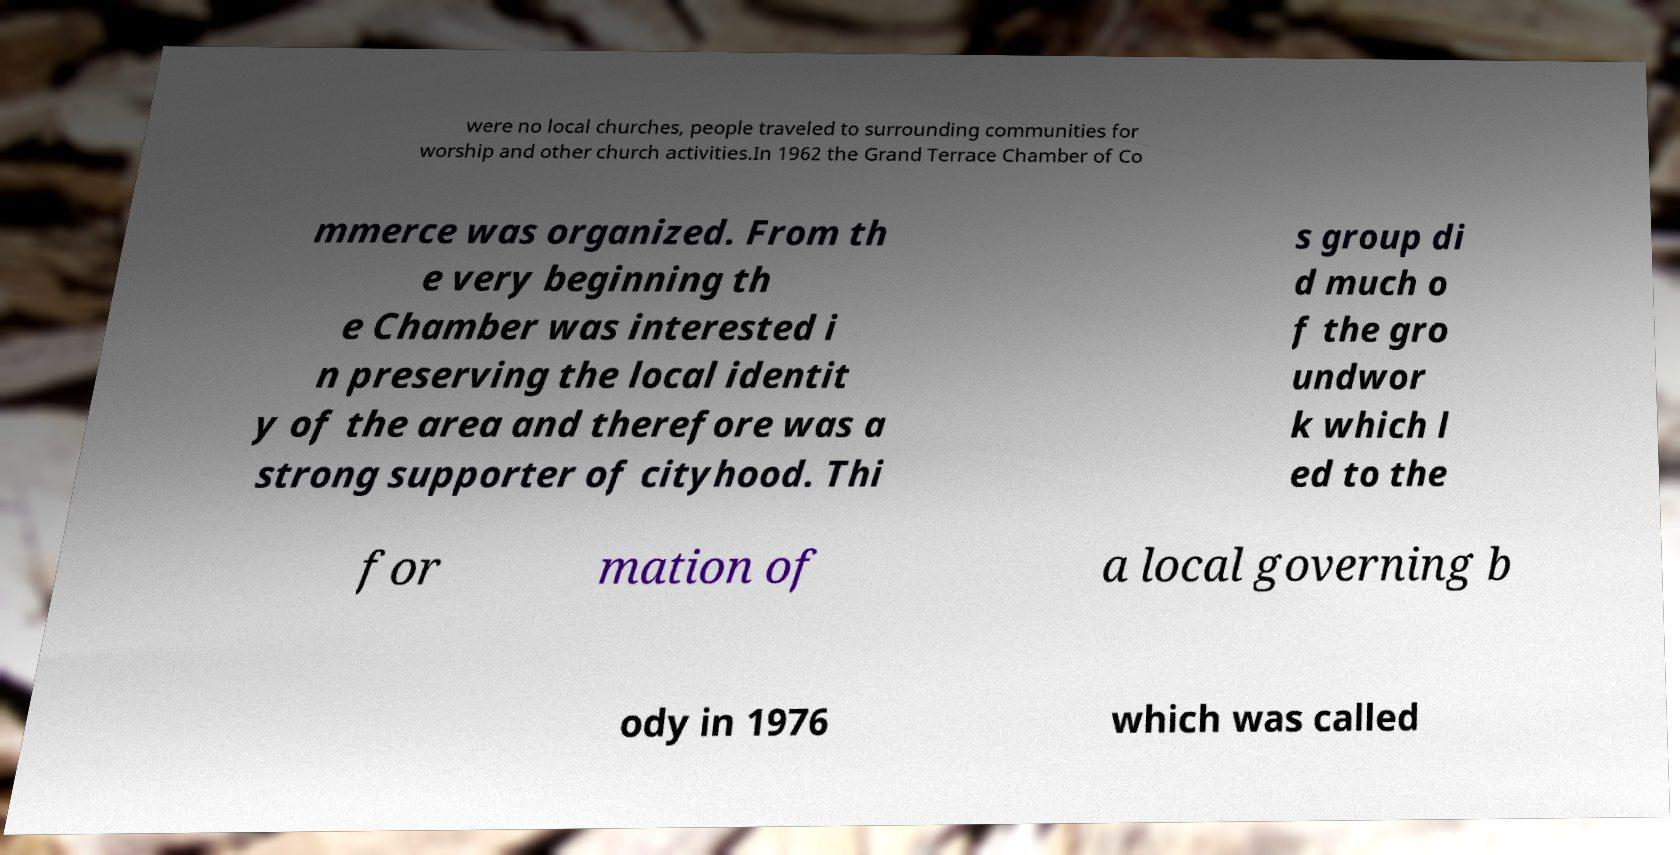Please identify and transcribe the text found in this image. were no local churches, people traveled to surrounding communities for worship and other church activities.In 1962 the Grand Terrace Chamber of Co mmerce was organized. From th e very beginning th e Chamber was interested i n preserving the local identit y of the area and therefore was a strong supporter of cityhood. Thi s group di d much o f the gro undwor k which l ed to the for mation of a local governing b ody in 1976 which was called 